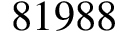<formula> <loc_0><loc_0><loc_500><loc_500>8 1 9 8 8</formula> 